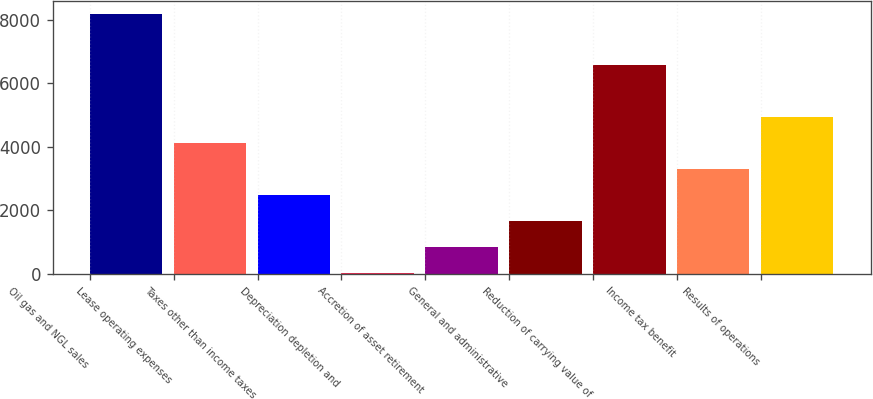<chart> <loc_0><loc_0><loc_500><loc_500><bar_chart><fcel>Oil gas and NGL sales<fcel>Lease operating expenses<fcel>Taxes other than income taxes<fcel>Depreciation depletion and<fcel>Accretion of asset retirement<fcel>General and administrative<fcel>Reduction of carrying value of<fcel>Income tax benefit<fcel>Results of operations<nl><fcel>8206<fcel>4109.16<fcel>2470.42<fcel>12.31<fcel>831.68<fcel>1651.05<fcel>6567.27<fcel>3289.79<fcel>4928.53<nl></chart> 